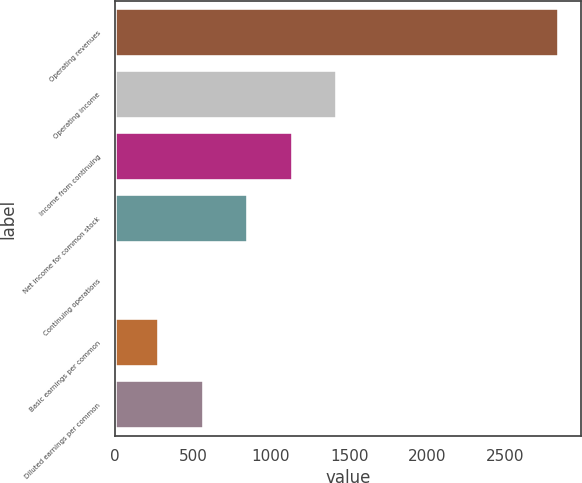Convert chart to OTSL. <chart><loc_0><loc_0><loc_500><loc_500><bar_chart><fcel>Operating revenues<fcel>Operating income<fcel>Income from continuing<fcel>Net income for common stock<fcel>Continuing operations<fcel>Basic earnings per common<fcel>Diluted earnings per common<nl><fcel>2845<fcel>1422.77<fcel>1138.33<fcel>853.88<fcel>0.55<fcel>285<fcel>569.44<nl></chart> 